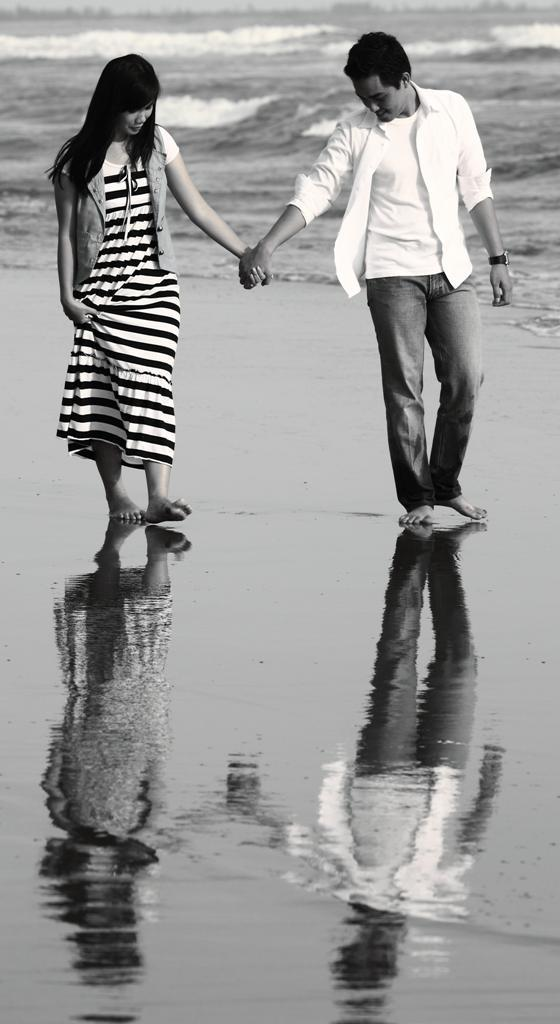What natural feature is present in the image? The image contains the sea. How many people are visible in the image? There are two persons visible in the image. What are the two persons doing? The two persons are holding hands and walking. What part of the sea can be seen in the image? The sea shore is visible in the image. What type of idea is being presented on the stage in the image? There is no stage or idea present in the image; it features the sea and two people walking while holding hands. What is the whip used for in the image? There is no whip present in the image. 